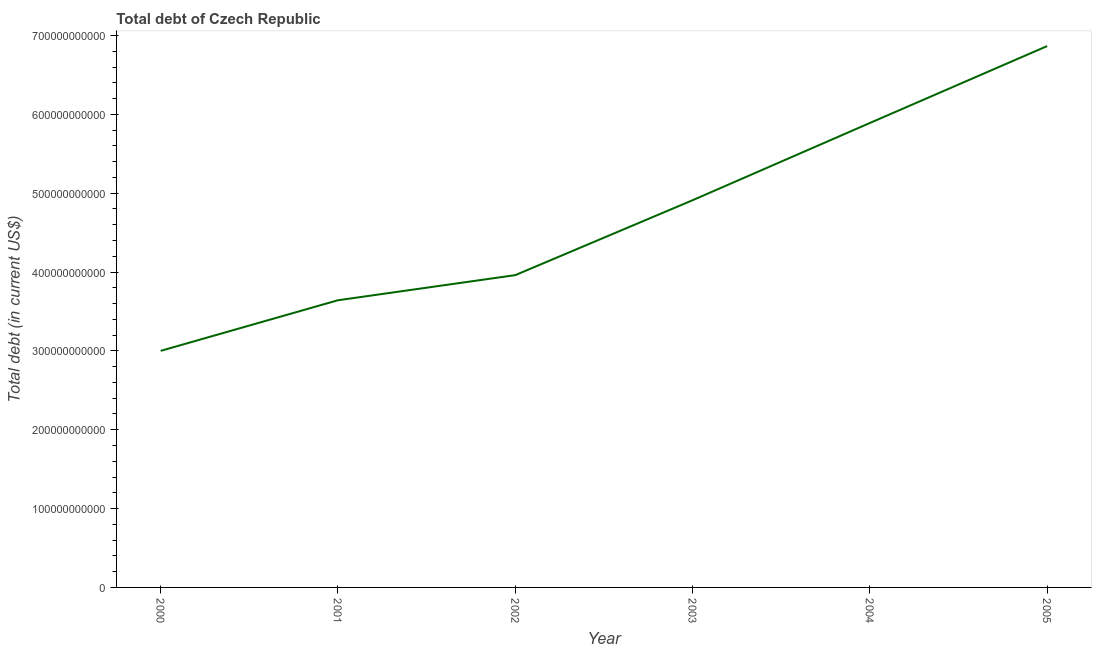What is the total debt in 2003?
Provide a short and direct response. 4.91e+11. Across all years, what is the maximum total debt?
Keep it short and to the point. 6.87e+11. Across all years, what is the minimum total debt?
Your answer should be compact. 3.00e+11. In which year was the total debt minimum?
Give a very brief answer. 2000. What is the sum of the total debt?
Provide a succinct answer. 2.83e+12. What is the difference between the total debt in 2002 and 2005?
Give a very brief answer. -2.91e+11. What is the average total debt per year?
Keep it short and to the point. 4.71e+11. What is the median total debt?
Provide a succinct answer. 4.44e+11. What is the ratio of the total debt in 2000 to that in 2001?
Provide a succinct answer. 0.82. Is the total debt in 2000 less than that in 2002?
Ensure brevity in your answer.  Yes. What is the difference between the highest and the second highest total debt?
Make the answer very short. 9.76e+1. What is the difference between the highest and the lowest total debt?
Give a very brief answer. 3.87e+11. In how many years, is the total debt greater than the average total debt taken over all years?
Provide a succinct answer. 3. Does the total debt monotonically increase over the years?
Provide a succinct answer. Yes. How many years are there in the graph?
Make the answer very short. 6. What is the difference between two consecutive major ticks on the Y-axis?
Your response must be concise. 1.00e+11. What is the title of the graph?
Offer a terse response. Total debt of Czech Republic. What is the label or title of the X-axis?
Make the answer very short. Year. What is the label or title of the Y-axis?
Provide a succinct answer. Total debt (in current US$). What is the Total debt (in current US$) of 2000?
Keep it short and to the point. 3.00e+11. What is the Total debt (in current US$) of 2001?
Give a very brief answer. 3.64e+11. What is the Total debt (in current US$) of 2002?
Your response must be concise. 3.96e+11. What is the Total debt (in current US$) in 2003?
Your answer should be compact. 4.91e+11. What is the Total debt (in current US$) in 2004?
Make the answer very short. 5.89e+11. What is the Total debt (in current US$) of 2005?
Give a very brief answer. 6.87e+11. What is the difference between the Total debt (in current US$) in 2000 and 2001?
Make the answer very short. -6.42e+1. What is the difference between the Total debt (in current US$) in 2000 and 2002?
Your answer should be very brief. -9.60e+1. What is the difference between the Total debt (in current US$) in 2000 and 2003?
Offer a very short reply. -1.91e+11. What is the difference between the Total debt (in current US$) in 2000 and 2004?
Your answer should be very brief. -2.89e+11. What is the difference between the Total debt (in current US$) in 2000 and 2005?
Make the answer very short. -3.87e+11. What is the difference between the Total debt (in current US$) in 2001 and 2002?
Your answer should be compact. -3.18e+1. What is the difference between the Total debt (in current US$) in 2001 and 2003?
Keep it short and to the point. -1.27e+11. What is the difference between the Total debt (in current US$) in 2001 and 2004?
Ensure brevity in your answer.  -2.25e+11. What is the difference between the Total debt (in current US$) in 2001 and 2005?
Keep it short and to the point. -3.22e+11. What is the difference between the Total debt (in current US$) in 2002 and 2003?
Make the answer very short. -9.50e+1. What is the difference between the Total debt (in current US$) in 2002 and 2004?
Offer a terse response. -1.93e+11. What is the difference between the Total debt (in current US$) in 2002 and 2005?
Ensure brevity in your answer.  -2.91e+11. What is the difference between the Total debt (in current US$) in 2003 and 2004?
Your answer should be compact. -9.80e+1. What is the difference between the Total debt (in current US$) in 2003 and 2005?
Offer a very short reply. -1.96e+11. What is the difference between the Total debt (in current US$) in 2004 and 2005?
Offer a terse response. -9.76e+1. What is the ratio of the Total debt (in current US$) in 2000 to that in 2001?
Provide a succinct answer. 0.82. What is the ratio of the Total debt (in current US$) in 2000 to that in 2002?
Your response must be concise. 0.76. What is the ratio of the Total debt (in current US$) in 2000 to that in 2003?
Make the answer very short. 0.61. What is the ratio of the Total debt (in current US$) in 2000 to that in 2004?
Your response must be concise. 0.51. What is the ratio of the Total debt (in current US$) in 2000 to that in 2005?
Your response must be concise. 0.44. What is the ratio of the Total debt (in current US$) in 2001 to that in 2003?
Make the answer very short. 0.74. What is the ratio of the Total debt (in current US$) in 2001 to that in 2004?
Provide a succinct answer. 0.62. What is the ratio of the Total debt (in current US$) in 2001 to that in 2005?
Keep it short and to the point. 0.53. What is the ratio of the Total debt (in current US$) in 2002 to that in 2003?
Ensure brevity in your answer.  0.81. What is the ratio of the Total debt (in current US$) in 2002 to that in 2004?
Your answer should be very brief. 0.67. What is the ratio of the Total debt (in current US$) in 2002 to that in 2005?
Offer a very short reply. 0.58. What is the ratio of the Total debt (in current US$) in 2003 to that in 2004?
Offer a very short reply. 0.83. What is the ratio of the Total debt (in current US$) in 2003 to that in 2005?
Make the answer very short. 0.71. What is the ratio of the Total debt (in current US$) in 2004 to that in 2005?
Offer a very short reply. 0.86. 